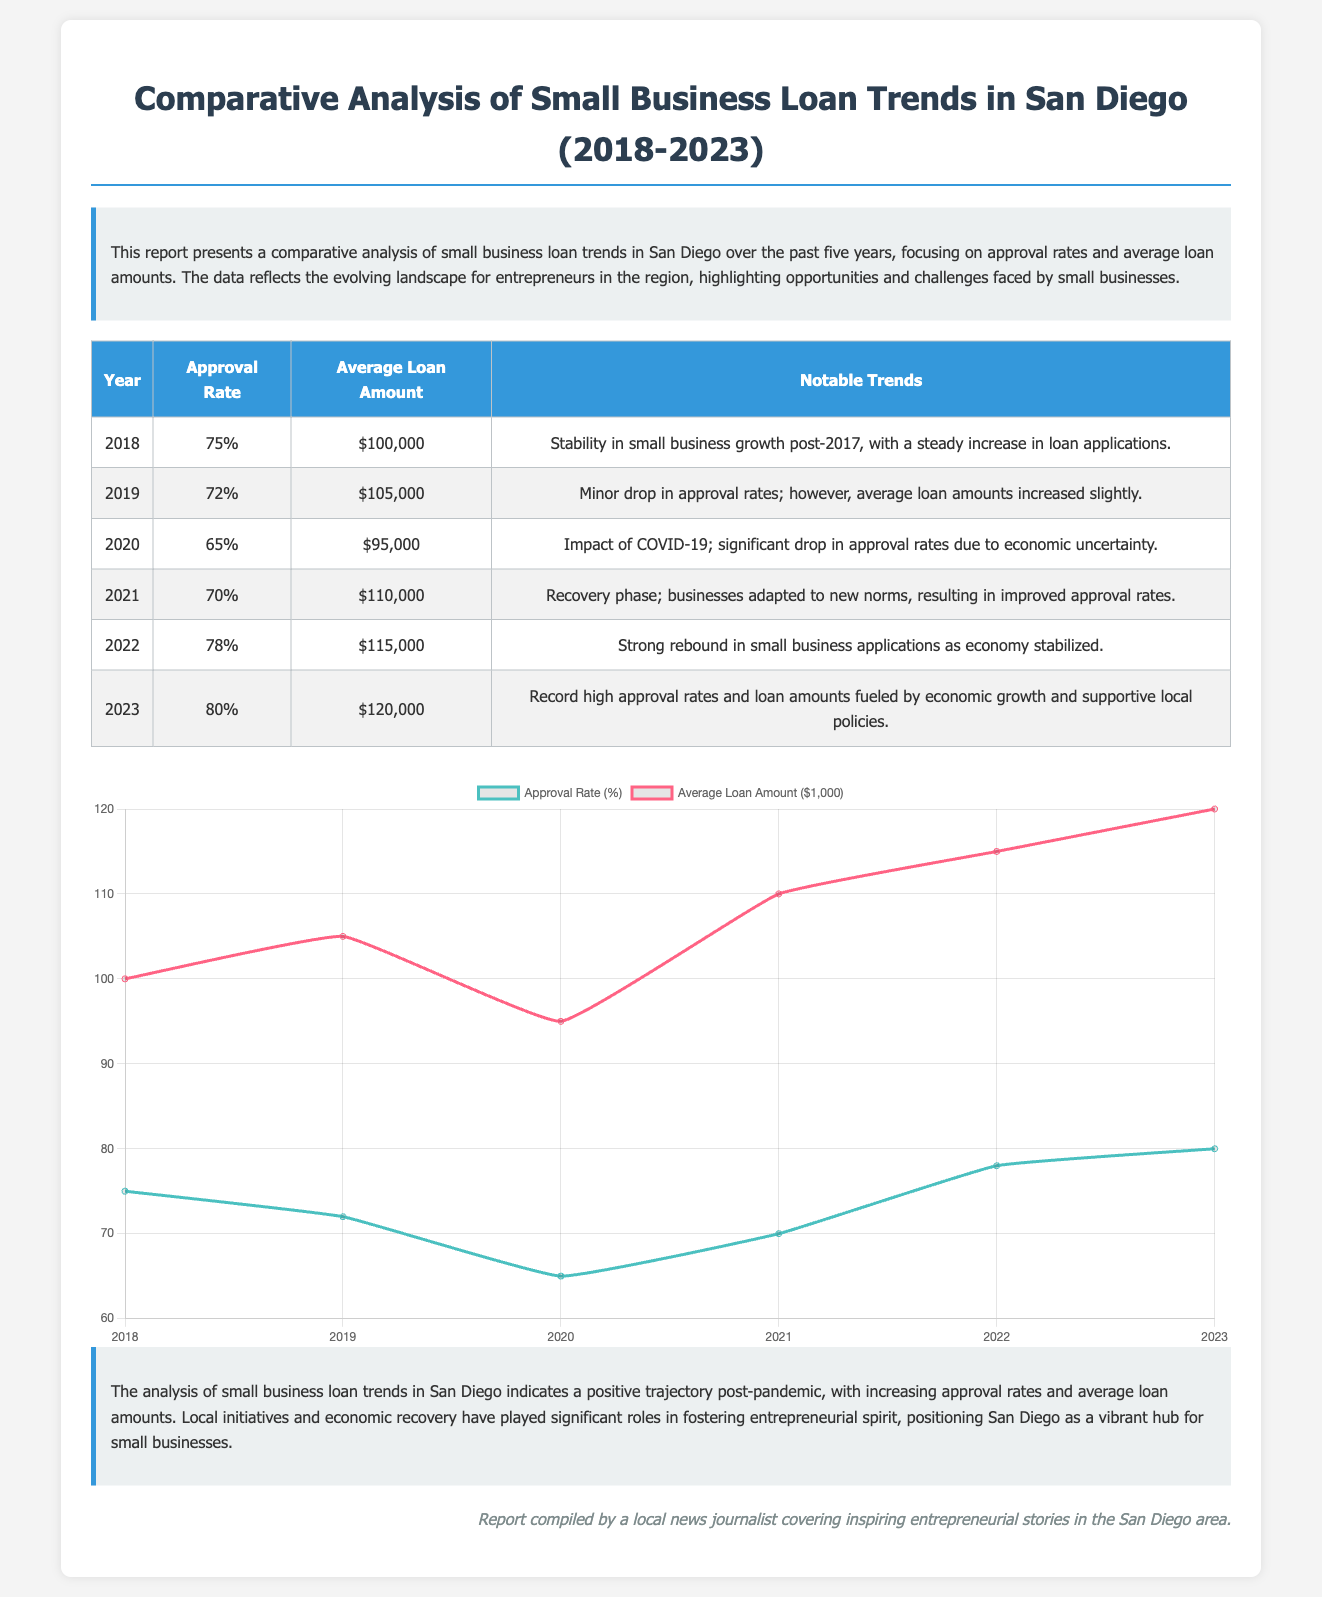What was the approval rate in 2022? The approval rate for 2022 is provided in the data table of the report.
Answer: 78% What was the average loan amount in 2020? The average loan amount for 2020 can be found in the report's data table.
Answer: $95,000 What notable trend occurred in 2021? The notable trend for 2021 is mentioned in the data table, summarizing the situation that year.
Answer: Recovery phase What was the highest approval rate recorded during the five years? To determine the highest approval rate, one must review the approval rate values across the years listed in the table.
Answer: 80% What was the average loan amount in 2019? The average loan amount for 2019 is found in the data table under the corresponding year.
Answer: $105,000 What trend is noted for the year 2023? The notable trend for 2023 is described in the data table, highlighting the situation during that year.
Answer: Record high approval rates What was the approval rate in 2018? The approval rate for 2018 is explicitly stated in the data table of the report.
Answer: 75% Which year saw the lowest average loan amount? The year with the lowest average loan amount can be determined by analyzing the provided data.
Answer: 2020 What year experienced a significant drop in approval rates due to COVID-19? The year that experienced this drop is mentioned in the notable trends section of the data table.
Answer: 2020 